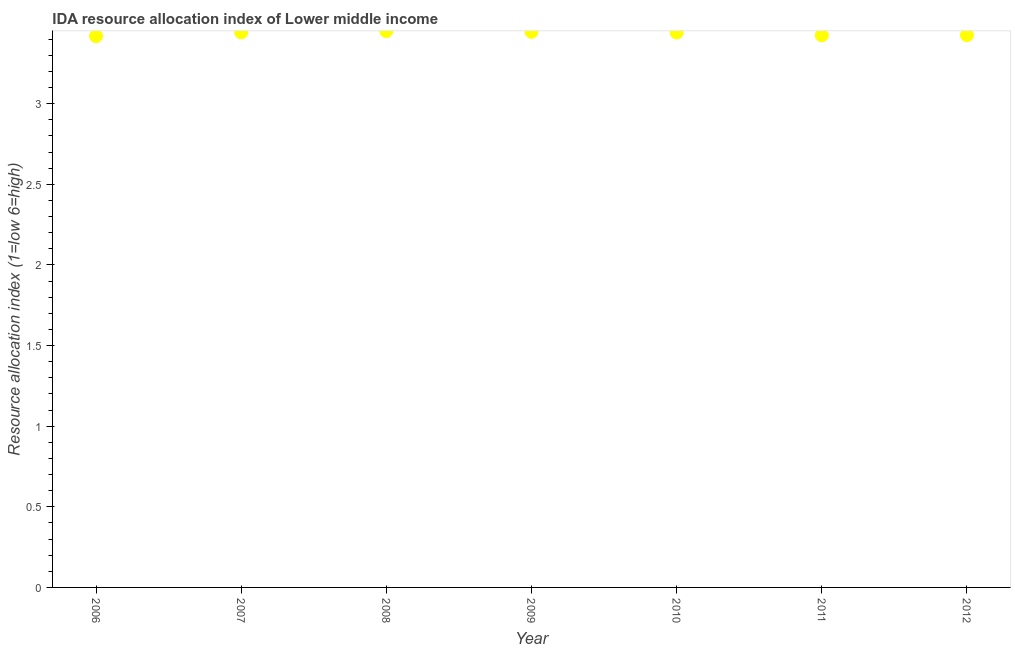What is the ida resource allocation index in 2008?
Your answer should be very brief. 3.45. Across all years, what is the maximum ida resource allocation index?
Offer a terse response. 3.45. Across all years, what is the minimum ida resource allocation index?
Give a very brief answer. 3.42. In which year was the ida resource allocation index maximum?
Ensure brevity in your answer.  2008. What is the sum of the ida resource allocation index?
Provide a short and direct response. 24.05. What is the difference between the ida resource allocation index in 2007 and 2011?
Your answer should be very brief. 0.02. What is the average ida resource allocation index per year?
Your response must be concise. 3.44. What is the median ida resource allocation index?
Provide a succinct answer. 3.44. In how many years, is the ida resource allocation index greater than 2.3 ?
Give a very brief answer. 7. Do a majority of the years between 2012 and 2007 (inclusive) have ida resource allocation index greater than 1.7 ?
Make the answer very short. Yes. What is the ratio of the ida resource allocation index in 2006 to that in 2012?
Provide a succinct answer. 1. Is the ida resource allocation index in 2011 less than that in 2012?
Your answer should be very brief. Yes. What is the difference between the highest and the second highest ida resource allocation index?
Your answer should be compact. 0. What is the difference between the highest and the lowest ida resource allocation index?
Give a very brief answer. 0.03. In how many years, is the ida resource allocation index greater than the average ida resource allocation index taken over all years?
Keep it short and to the point. 4. How many dotlines are there?
Offer a terse response. 1. How many years are there in the graph?
Provide a succinct answer. 7. What is the title of the graph?
Offer a very short reply. IDA resource allocation index of Lower middle income. What is the label or title of the X-axis?
Your answer should be compact. Year. What is the label or title of the Y-axis?
Offer a very short reply. Resource allocation index (1=low 6=high). What is the Resource allocation index (1=low 6=high) in 2006?
Your answer should be compact. 3.42. What is the Resource allocation index (1=low 6=high) in 2007?
Ensure brevity in your answer.  3.44. What is the Resource allocation index (1=low 6=high) in 2008?
Offer a very short reply. 3.45. What is the Resource allocation index (1=low 6=high) in 2009?
Offer a very short reply. 3.45. What is the Resource allocation index (1=low 6=high) in 2010?
Give a very brief answer. 3.44. What is the Resource allocation index (1=low 6=high) in 2011?
Keep it short and to the point. 3.42. What is the Resource allocation index (1=low 6=high) in 2012?
Keep it short and to the point. 3.42. What is the difference between the Resource allocation index (1=low 6=high) in 2006 and 2007?
Ensure brevity in your answer.  -0.02. What is the difference between the Resource allocation index (1=low 6=high) in 2006 and 2008?
Provide a succinct answer. -0.03. What is the difference between the Resource allocation index (1=low 6=high) in 2006 and 2009?
Ensure brevity in your answer.  -0.03. What is the difference between the Resource allocation index (1=low 6=high) in 2006 and 2010?
Make the answer very short. -0.02. What is the difference between the Resource allocation index (1=low 6=high) in 2006 and 2011?
Ensure brevity in your answer.  -0.01. What is the difference between the Resource allocation index (1=low 6=high) in 2006 and 2012?
Your response must be concise. -0.01. What is the difference between the Resource allocation index (1=low 6=high) in 2007 and 2008?
Keep it short and to the point. -0.01. What is the difference between the Resource allocation index (1=low 6=high) in 2007 and 2009?
Provide a short and direct response. -0. What is the difference between the Resource allocation index (1=low 6=high) in 2007 and 2010?
Your response must be concise. 0. What is the difference between the Resource allocation index (1=low 6=high) in 2007 and 2011?
Your response must be concise. 0.02. What is the difference between the Resource allocation index (1=low 6=high) in 2007 and 2012?
Your response must be concise. 0.02. What is the difference between the Resource allocation index (1=low 6=high) in 2008 and 2009?
Your answer should be very brief. 0. What is the difference between the Resource allocation index (1=low 6=high) in 2008 and 2010?
Give a very brief answer. 0.01. What is the difference between the Resource allocation index (1=low 6=high) in 2008 and 2011?
Provide a short and direct response. 0.03. What is the difference between the Resource allocation index (1=low 6=high) in 2008 and 2012?
Your answer should be compact. 0.03. What is the difference between the Resource allocation index (1=low 6=high) in 2009 and 2010?
Your answer should be very brief. 0. What is the difference between the Resource allocation index (1=low 6=high) in 2009 and 2011?
Keep it short and to the point. 0.02. What is the difference between the Resource allocation index (1=low 6=high) in 2009 and 2012?
Offer a very short reply. 0.02. What is the difference between the Resource allocation index (1=low 6=high) in 2010 and 2011?
Offer a very short reply. 0.02. What is the difference between the Resource allocation index (1=low 6=high) in 2010 and 2012?
Your response must be concise. 0.02. What is the difference between the Resource allocation index (1=low 6=high) in 2011 and 2012?
Your answer should be compact. -0. What is the ratio of the Resource allocation index (1=low 6=high) in 2006 to that in 2009?
Offer a terse response. 0.99. What is the ratio of the Resource allocation index (1=low 6=high) in 2006 to that in 2010?
Keep it short and to the point. 0.99. What is the ratio of the Resource allocation index (1=low 6=high) in 2006 to that in 2011?
Provide a short and direct response. 1. What is the ratio of the Resource allocation index (1=low 6=high) in 2007 to that in 2008?
Keep it short and to the point. 1. What is the ratio of the Resource allocation index (1=low 6=high) in 2007 to that in 2009?
Your answer should be compact. 1. What is the ratio of the Resource allocation index (1=low 6=high) in 2007 to that in 2011?
Ensure brevity in your answer.  1. What is the ratio of the Resource allocation index (1=low 6=high) in 2008 to that in 2010?
Offer a very short reply. 1. What is the ratio of the Resource allocation index (1=low 6=high) in 2008 to that in 2011?
Provide a succinct answer. 1.01. What is the ratio of the Resource allocation index (1=low 6=high) in 2008 to that in 2012?
Your response must be concise. 1.01. What is the ratio of the Resource allocation index (1=low 6=high) in 2009 to that in 2011?
Your answer should be compact. 1.01. What is the ratio of the Resource allocation index (1=low 6=high) in 2009 to that in 2012?
Offer a terse response. 1.01. What is the ratio of the Resource allocation index (1=low 6=high) in 2010 to that in 2012?
Your answer should be very brief. 1. 